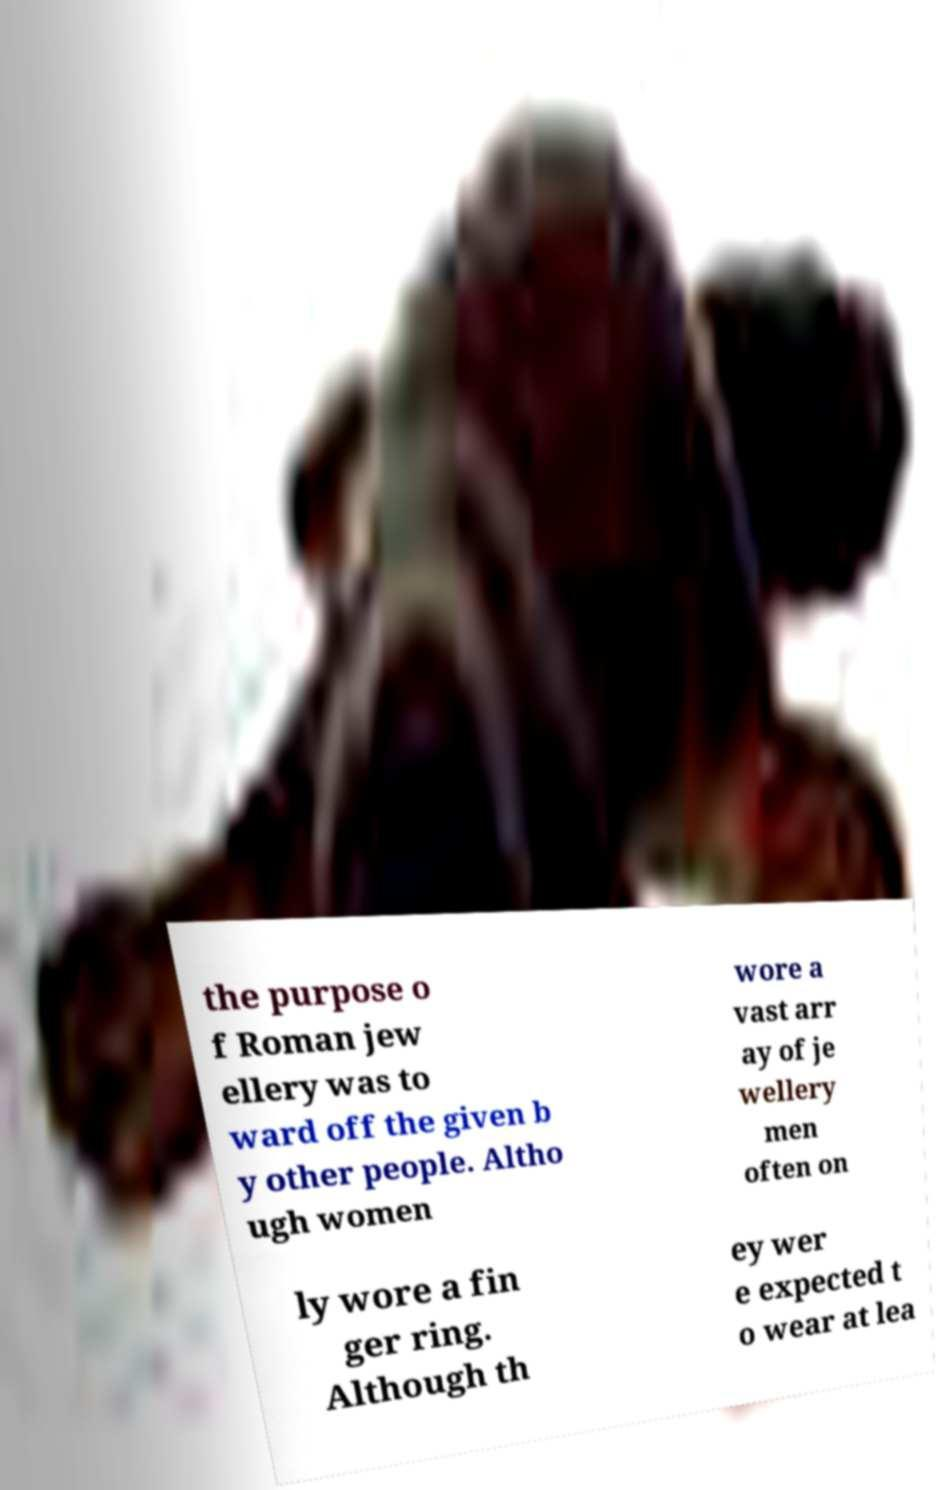Can you accurately transcribe the text from the provided image for me? the purpose o f Roman jew ellery was to ward off the given b y other people. Altho ugh women wore a vast arr ay of je wellery men often on ly wore a fin ger ring. Although th ey wer e expected t o wear at lea 